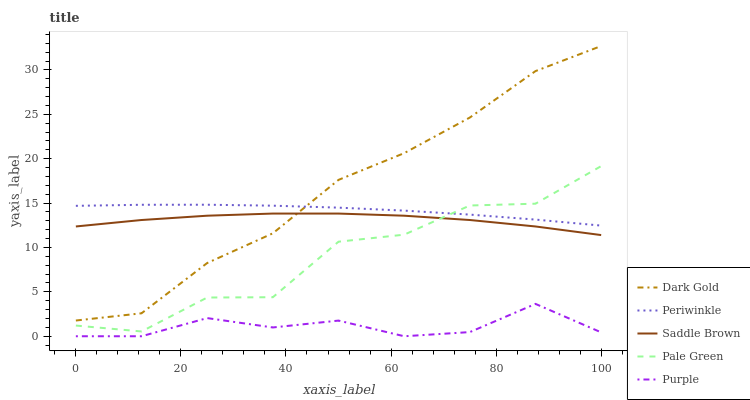Does Pale Green have the minimum area under the curve?
Answer yes or no. No. Does Pale Green have the maximum area under the curve?
Answer yes or no. No. Is Pale Green the smoothest?
Answer yes or no. No. Is Periwinkle the roughest?
Answer yes or no. No. Does Pale Green have the lowest value?
Answer yes or no. No. Does Pale Green have the highest value?
Answer yes or no. No. Is Purple less than Saddle Brown?
Answer yes or no. Yes. Is Dark Gold greater than Pale Green?
Answer yes or no. Yes. Does Purple intersect Saddle Brown?
Answer yes or no. No. 